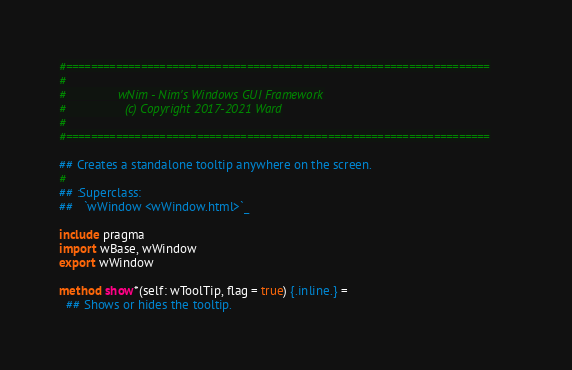<code> <loc_0><loc_0><loc_500><loc_500><_Nim_>#====================================================================
#
#               wNim - Nim's Windows GUI Framework
#                 (c) Copyright 2017-2021 Ward
#
#====================================================================

## Creates a standalone tooltip anywhere on the screen.
#
## :Superclass:
##   `wWindow <wWindow.html>`_

include pragma
import wBase, wWindow
export wWindow

method show*(self: wToolTip, flag = true) {.inline.} =
  ## Shows or hides the tooltip.</code> 